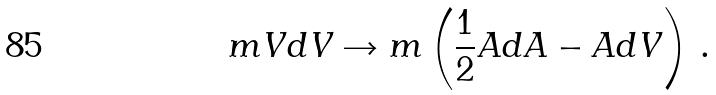Convert formula to latex. <formula><loc_0><loc_0><loc_500><loc_500>m V d V \rightarrow m \left ( { { \frac { 1 } { 2 } } } A d A - A d V \right ) \, .</formula> 